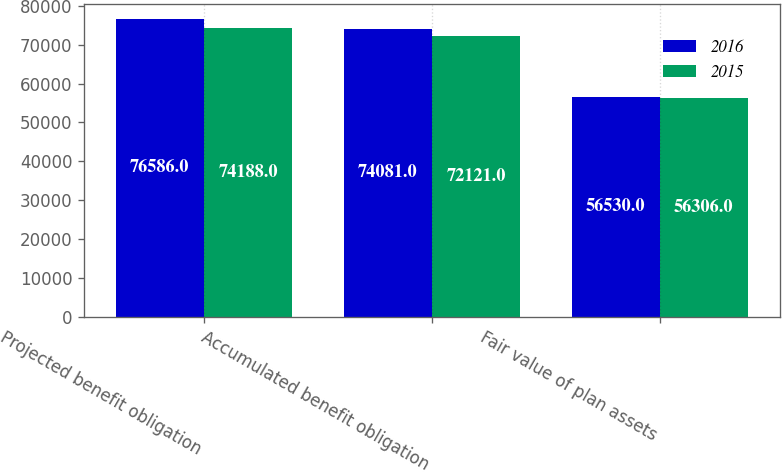<chart> <loc_0><loc_0><loc_500><loc_500><stacked_bar_chart><ecel><fcel>Projected benefit obligation<fcel>Accumulated benefit obligation<fcel>Fair value of plan assets<nl><fcel>2016<fcel>76586<fcel>74081<fcel>56530<nl><fcel>2015<fcel>74188<fcel>72121<fcel>56306<nl></chart> 